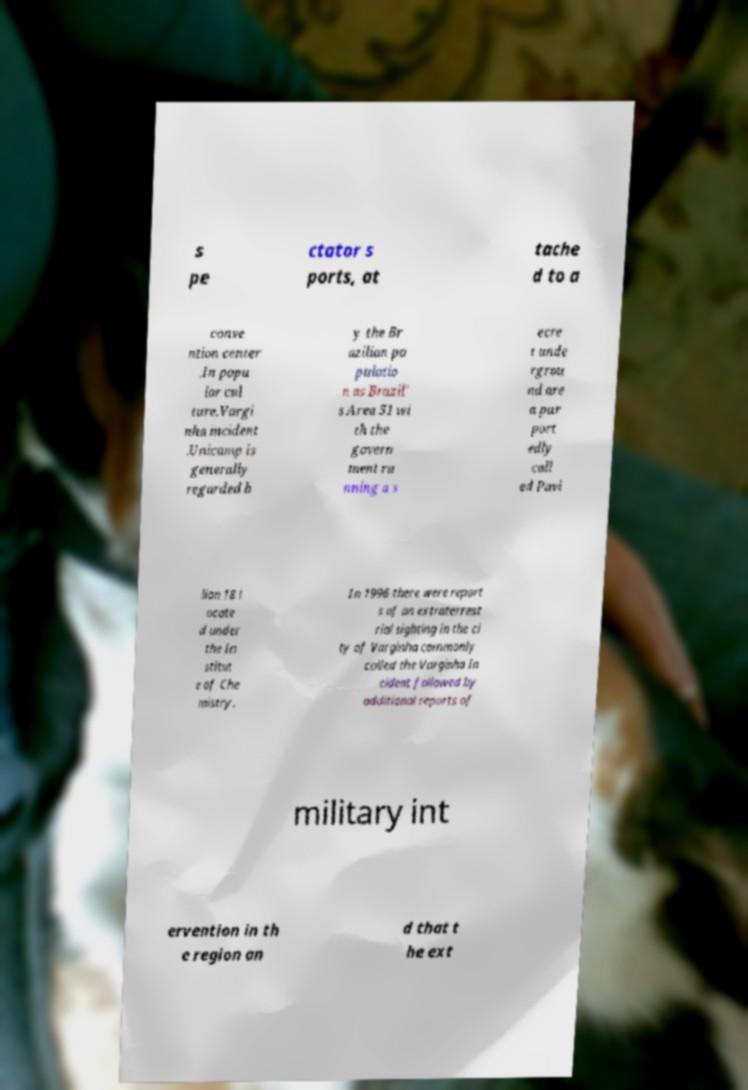What messages or text are displayed in this image? I need them in a readable, typed format. s pe ctator s ports, at tache d to a conve ntion center .In popu lar cul ture.Vargi nha incident .Unicamp is generally regarded b y the Br azilian po pulatio n as Brazil' s Area 51 wi th the govern ment ru nning a s ecre t unde rgrou nd are a pur port edly call ed Pavi lion 18 l ocate d under the In stitut e of Che mistry. In 1996 there were report s of an extraterrest rial sighting in the ci ty of Varginha commonly called the Varginha In cident followed by additional reports of military int ervention in th e region an d that t he ext 